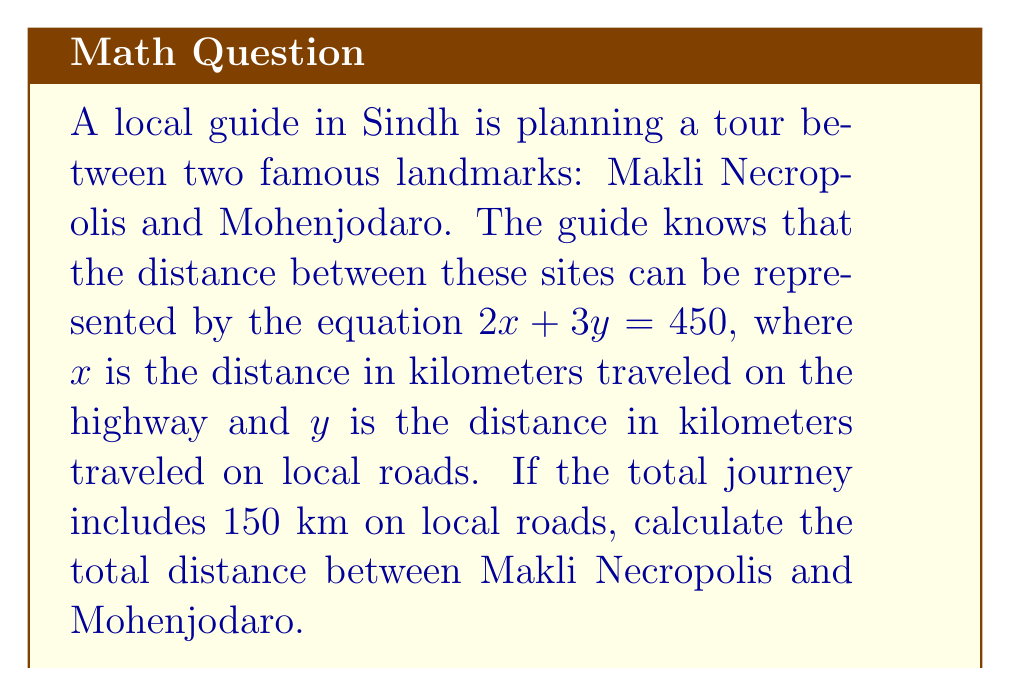Provide a solution to this math problem. Let's solve this problem step by step:

1) We are given the equation: $2x + 3y = 450$

2) We know that $y = 150$ km (distance traveled on local roads)

3) Let's substitute $y = 150$ into the equation:
   $2x + 3(150) = 450$

4) Simplify:
   $2x + 450 = 450$

5) Subtract 450 from both sides:
   $2x = 0$

6) Divide both sides by 2:
   $x = 0$

7) This means the distance traveled on the highway is 0 km.

8) The total distance is the sum of highway distance ($x$) and local road distance ($y$):
   Total distance = $x + y = 0 + 150 = 150$ km

Therefore, the total distance between Makli Necropolis and Mohenjodaro is 150 km.
Answer: 150 km 